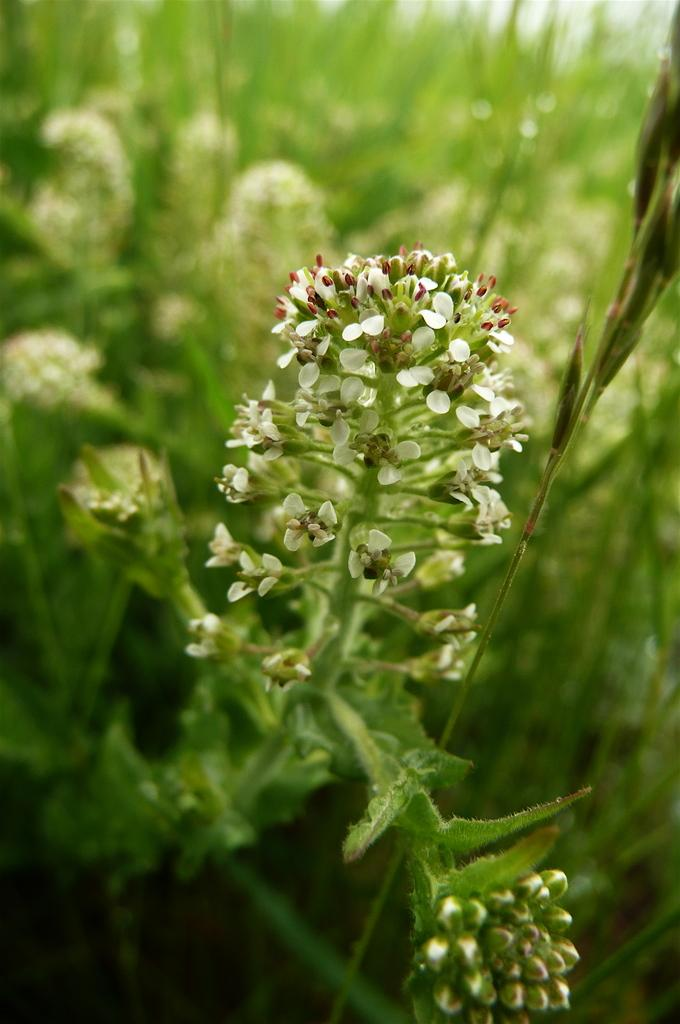What type of living organisms can be seen in the image? There are flowers in the image. What do the flowers belong to? The flowers belong to a plant. What type of yam is being used for comfort in the image? There is no yam present in the image, and the concept of using a yam for comfort is not relevant to the image. 